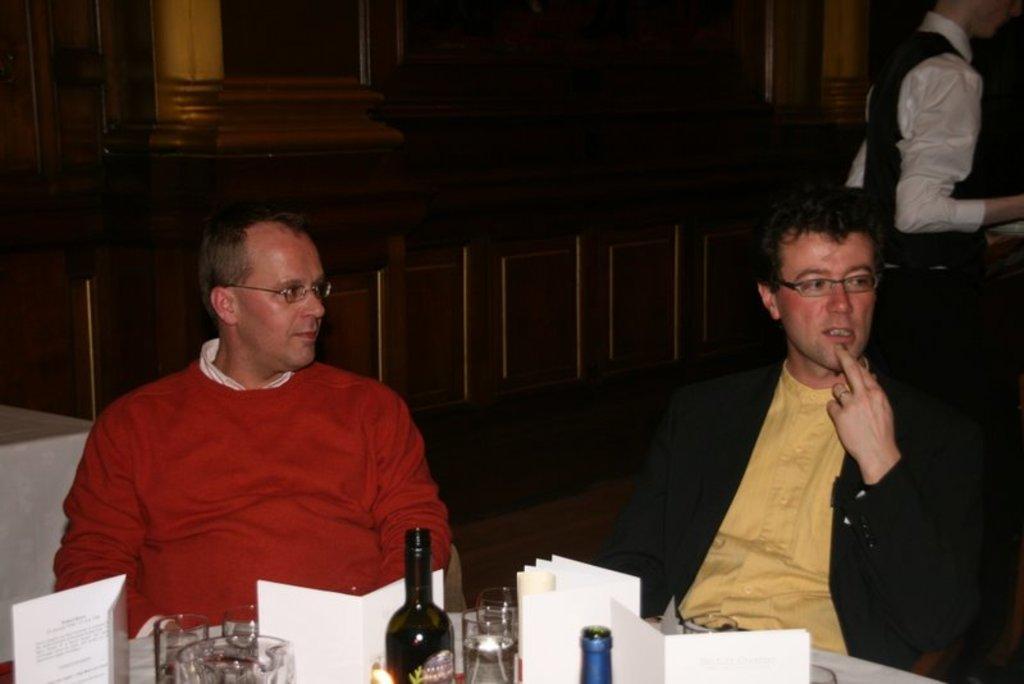In one or two sentences, can you explain what this image depicts? In the image there is a table, on the table there are some glasses, books and bottles. There are two men sitting behind the table and in the background there are wooden cupboards and on the right side there is a server. 